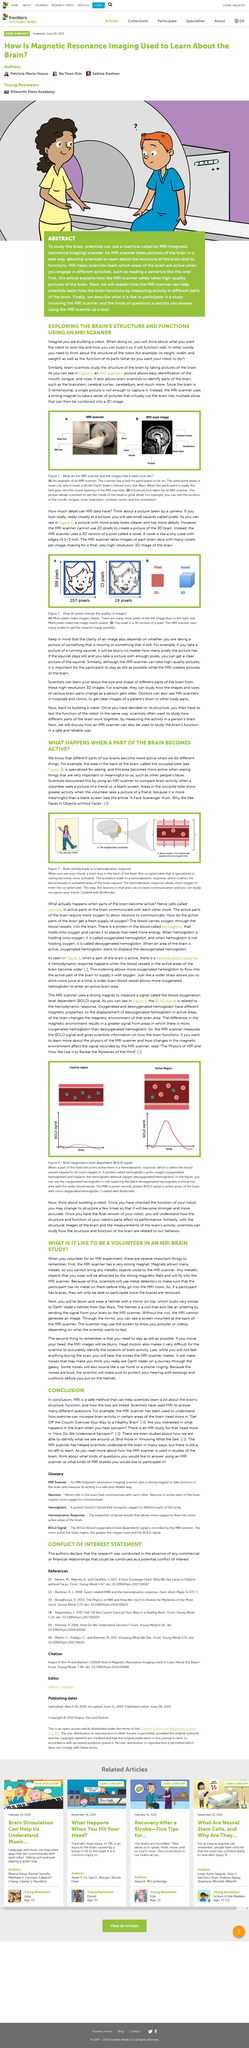Specify some key components in this picture. The machine in figure 1A is called an MRI scanner. The clarity of a picture depends on whether it is taken of something that is moving or something that is still. The above picture portrays the BOLD signal, which is a measure of blood oxygenation level. The brain parts referred to in the text are the brain stem, cerebral cortex, and cerebellum. When building a robot, it is essential to consider both its structure and function. 